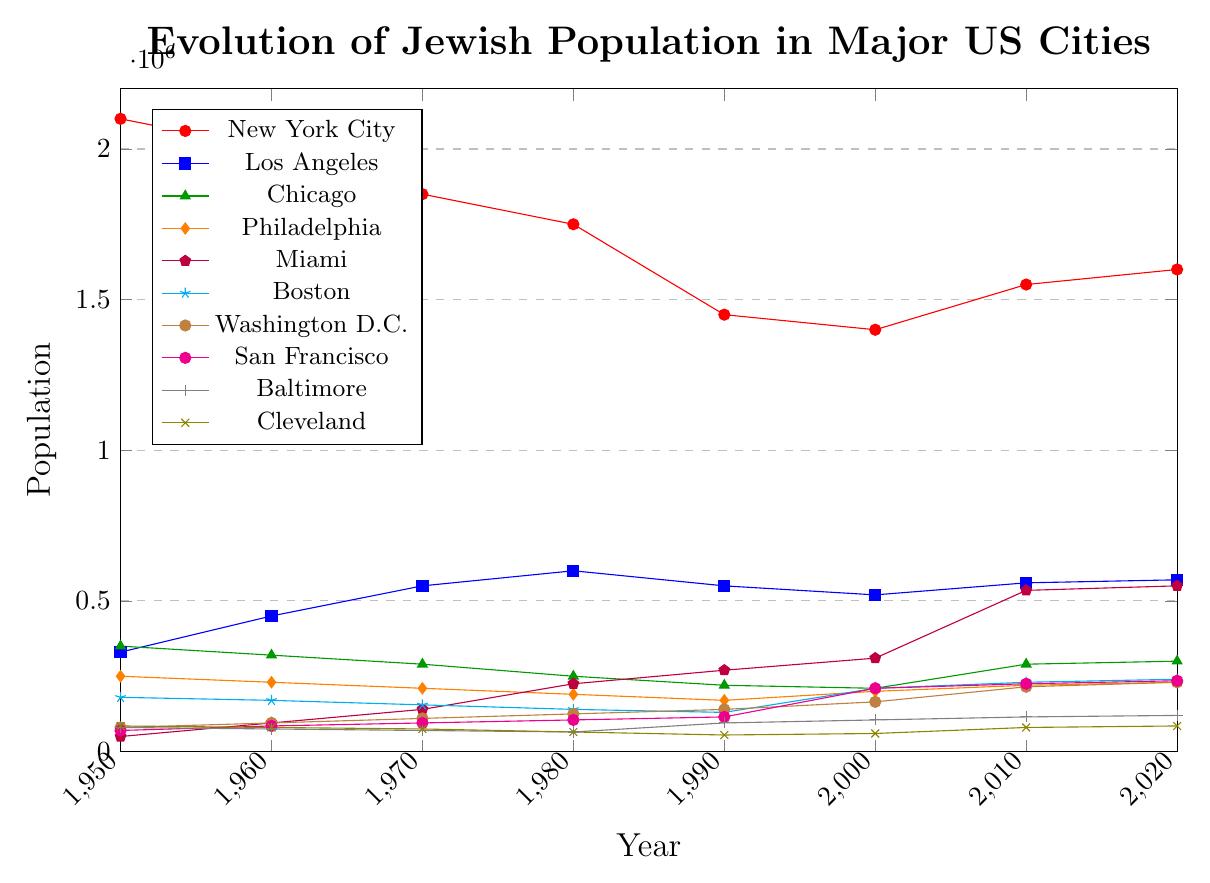What is the general trend of the Jewish population in New York City from 1950 to 2020? The population decreases from 1950 to 2000, then increases again in 2010 and 2020.
Answer: It shows a decline followed by a slight increase Which city had the highest Jewish population in 1950? By looking at the highest point in 1950, New York City had the highest population.
Answer: New York City How did the Jewish population in Miami change from 1960 to 2020? The population increased consistently from 95,000 in 1960 to 550,000 in 2020.
Answer: It steadily increased Compare the Jewish population in Boston and Philadelphia in the year 2000. Which city had a higher population? Boston had 210,000 while Philadelphia had 200,000. Hence, Boston had a higher population.
Answer: Boston What is the total Jewish population in Los Angeles and Chicago in 2020? Los Angeles had 570,000 and Chicago had 300,000. Adding them gives a total of 570,000 + 300,000 = 870,000.
Answer: 870,000 Identify the city with the largest relative increase in Jewish population from 1950 to 2020. Miami grew from 50,000 in 1950 to 550,000 in 2020, which is the largest relative increase among the cities listed.
Answer: Miami Which city experienced the smallest overall change in Jewish population from 1950 to 2020? Cleveland's population went from 85,000 in 1950 to 85,000 in 2020, showing no change.
Answer: Cleveland Between 2000 and 2020, which city showed the most significant growth in Jewish population? By examining the end points, Miami grew from 310,000 in 2000 to 550,000 in 2020.
Answer: Miami Did the Jewish population in Baltimore increase, decrease, or stay the same between 1980 and 2020? The population increased from 65,000 in 1980 to 120,000 in 2020.
Answer: Increased Which city had a higher Jewish population in 2020, Washington D.C., or Boston? Washington D.C. had 230,000, and Boston had 240,000 in 2020.
Answer: Boston 